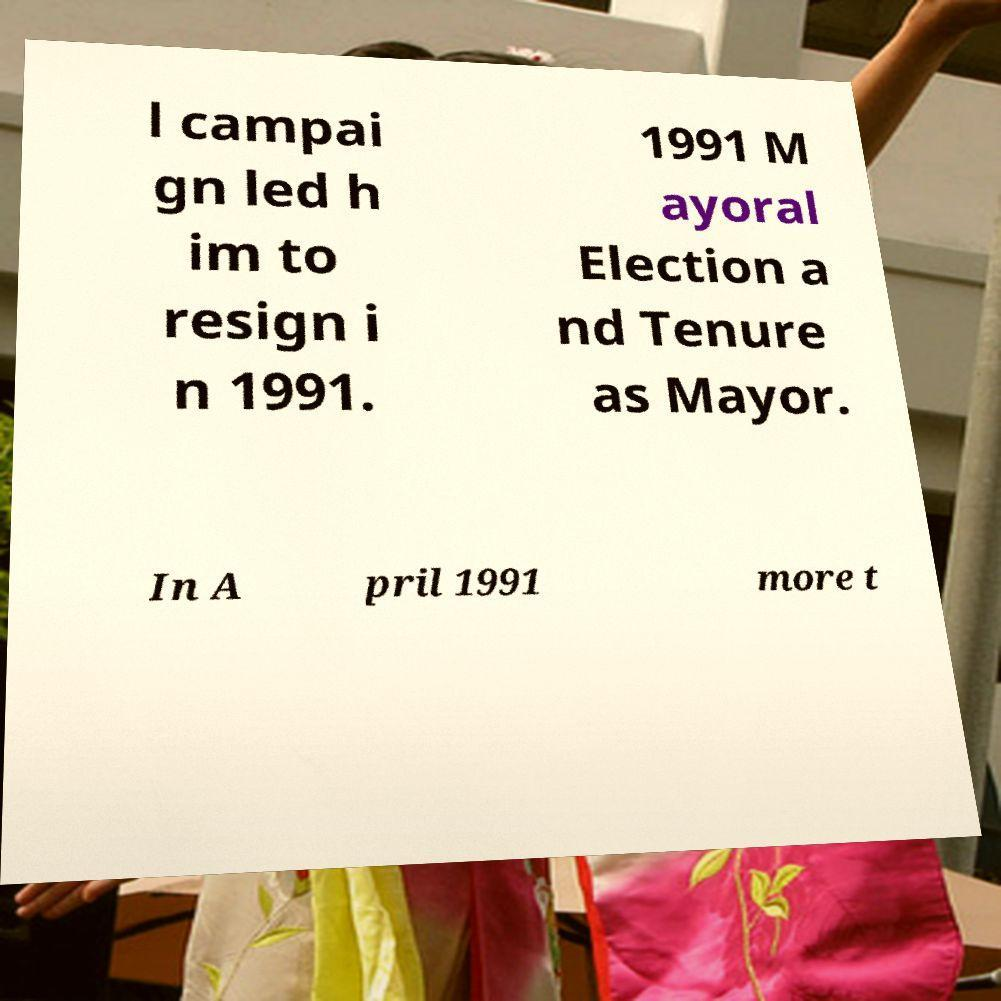Could you assist in decoding the text presented in this image and type it out clearly? l campai gn led h im to resign i n 1991. 1991 M ayoral Election a nd Tenure as Mayor. In A pril 1991 more t 